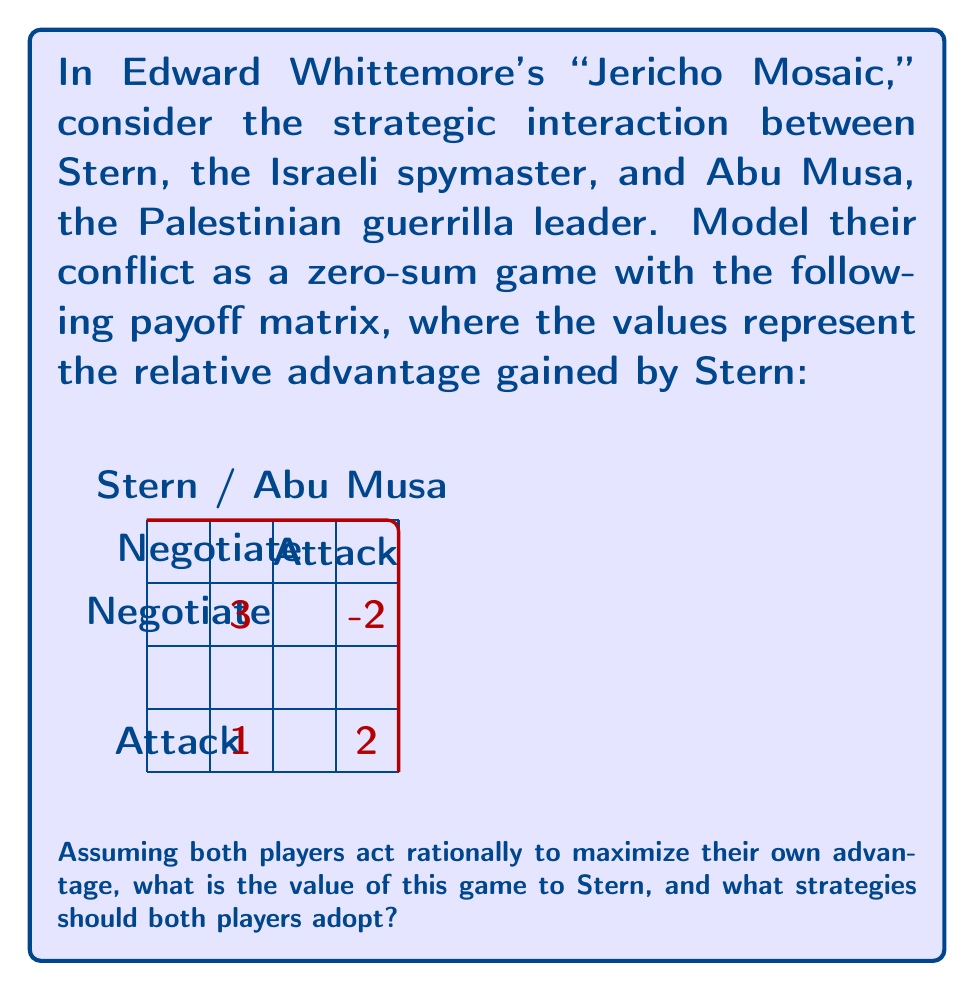Solve this math problem. To solve this zero-sum game, we'll follow these steps:

1) First, we need to find the maximin and minimax values:

   For Stern (row player):
   - If he chooses "Negotiate": min(3, 1) = 1
   - If he chooses "Attack": min(-2, 2) = -2
   Maximin = max(1, -2) = 1

   For Abu Musa (column player):
   - If he chooses "Negotiate": max(3, 1) = 3
   - If he chooses "Attack": max(-2, 2) = 2
   Minimax = min(3, 2) = 2

2) Since the maximin ≠ minimax, there's no pure strategy equilibrium. We need to find mixed strategies.

3) Let's say Stern plays "Negotiate" with probability $p$ and "Attack" with probability $(1-p)$. For Abu Musa, let $q$ be the probability of "Negotiate" and $(1-q)$ for "Attack".

4) For Stern to be indifferent between his strategies:

   $3q + 1(1-q) = -2q + 2(1-q)$
   $3q + 1 - q = -2q + 2 - 2q$
   $2q + 1 = -4q + 2$
   $6q = 1$
   $q = \frac{1}{6}$

5) For Abu Musa to be indifferent:

   $3p + (-2)(1-p) = 1p + 2(1-p)$
   $3p - 2 + 2p = p + 2 - 2p$
   $5p - 2 = -p + 2$
   $6p = 4$
   $p = \frac{2}{3}$

6) The value of the game to Stern is:

   $V = 3(\frac{2}{3})(\frac{1}{6}) + (-2)(\frac{2}{3})(\frac{5}{6}) + 1(\frac{1}{3})(\frac{1}{6}) + 2(\frac{1}{3})(\frac{5}{6})$
   $= \frac{1}{3} - \frac{5}{6} + \frac{1}{18} + \frac{5}{9} = \frac{1}{3}$

Therefore, the value of the game to Stern is $\frac{1}{3}$, and the optimal strategies are:
- Stern: Play "Negotiate" with probability $\frac{2}{3}$ and "Attack" with probability $\frac{1}{3}$
- Abu Musa: Play "Negotiate" with probability $\frac{1}{6}$ and "Attack" with probability $\frac{5}{6}$
Answer: Value: $\frac{1}{3}$. Stern: $(\frac{2}{3}, \frac{1}{3})$, Abu Musa: $(\frac{1}{6}, \frac{5}{6})$ 